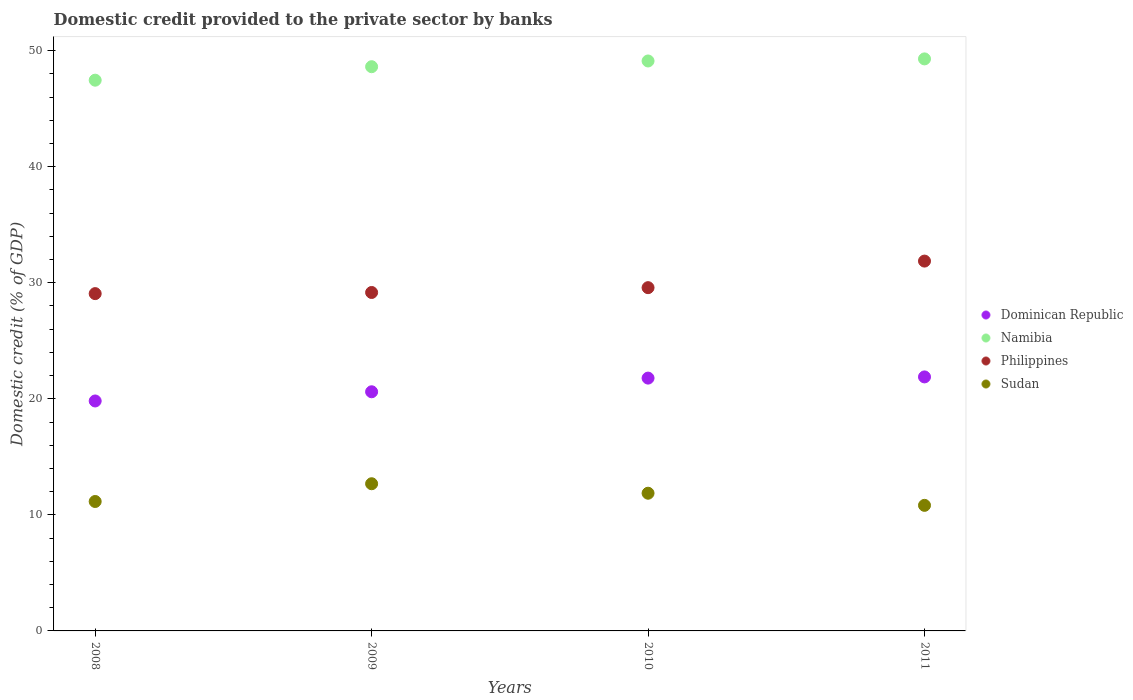How many different coloured dotlines are there?
Make the answer very short. 4. What is the domestic credit provided to the private sector by banks in Dominican Republic in 2009?
Give a very brief answer. 20.61. Across all years, what is the maximum domestic credit provided to the private sector by banks in Sudan?
Provide a short and direct response. 12.68. Across all years, what is the minimum domestic credit provided to the private sector by banks in Sudan?
Offer a very short reply. 10.82. In which year was the domestic credit provided to the private sector by banks in Philippines minimum?
Your response must be concise. 2008. What is the total domestic credit provided to the private sector by banks in Philippines in the graph?
Offer a terse response. 119.67. What is the difference between the domestic credit provided to the private sector by banks in Namibia in 2008 and that in 2011?
Ensure brevity in your answer.  -1.83. What is the difference between the domestic credit provided to the private sector by banks in Sudan in 2011 and the domestic credit provided to the private sector by banks in Dominican Republic in 2009?
Keep it short and to the point. -9.79. What is the average domestic credit provided to the private sector by banks in Namibia per year?
Provide a short and direct response. 48.62. In the year 2010, what is the difference between the domestic credit provided to the private sector by banks in Philippines and domestic credit provided to the private sector by banks in Namibia?
Your answer should be very brief. -19.53. What is the ratio of the domestic credit provided to the private sector by banks in Philippines in 2010 to that in 2011?
Provide a succinct answer. 0.93. Is the difference between the domestic credit provided to the private sector by banks in Philippines in 2009 and 2010 greater than the difference between the domestic credit provided to the private sector by banks in Namibia in 2009 and 2010?
Your answer should be compact. Yes. What is the difference between the highest and the second highest domestic credit provided to the private sector by banks in Philippines?
Your answer should be compact. 2.29. What is the difference between the highest and the lowest domestic credit provided to the private sector by banks in Sudan?
Offer a very short reply. 1.86. In how many years, is the domestic credit provided to the private sector by banks in Dominican Republic greater than the average domestic credit provided to the private sector by banks in Dominican Republic taken over all years?
Offer a terse response. 2. Is it the case that in every year, the sum of the domestic credit provided to the private sector by banks in Philippines and domestic credit provided to the private sector by banks in Dominican Republic  is greater than the sum of domestic credit provided to the private sector by banks in Namibia and domestic credit provided to the private sector by banks in Sudan?
Provide a short and direct response. No. Is the domestic credit provided to the private sector by banks in Sudan strictly greater than the domestic credit provided to the private sector by banks in Namibia over the years?
Your answer should be very brief. No. Is the domestic credit provided to the private sector by banks in Philippines strictly less than the domestic credit provided to the private sector by banks in Dominican Republic over the years?
Provide a succinct answer. No. How many dotlines are there?
Ensure brevity in your answer.  4. How many years are there in the graph?
Provide a succinct answer. 4. Are the values on the major ticks of Y-axis written in scientific E-notation?
Provide a succinct answer. No. Does the graph contain any zero values?
Keep it short and to the point. No. Where does the legend appear in the graph?
Offer a very short reply. Center right. How are the legend labels stacked?
Your answer should be very brief. Vertical. What is the title of the graph?
Provide a succinct answer. Domestic credit provided to the private sector by banks. What is the label or title of the X-axis?
Provide a short and direct response. Years. What is the label or title of the Y-axis?
Ensure brevity in your answer.  Domestic credit (% of GDP). What is the Domestic credit (% of GDP) of Dominican Republic in 2008?
Your answer should be compact. 19.81. What is the Domestic credit (% of GDP) of Namibia in 2008?
Your answer should be very brief. 47.46. What is the Domestic credit (% of GDP) of Philippines in 2008?
Your response must be concise. 29.06. What is the Domestic credit (% of GDP) in Sudan in 2008?
Give a very brief answer. 11.15. What is the Domestic credit (% of GDP) of Dominican Republic in 2009?
Offer a very short reply. 20.61. What is the Domestic credit (% of GDP) in Namibia in 2009?
Give a very brief answer. 48.62. What is the Domestic credit (% of GDP) in Philippines in 2009?
Offer a very short reply. 29.16. What is the Domestic credit (% of GDP) in Sudan in 2009?
Ensure brevity in your answer.  12.68. What is the Domestic credit (% of GDP) of Dominican Republic in 2010?
Give a very brief answer. 21.79. What is the Domestic credit (% of GDP) of Namibia in 2010?
Your answer should be very brief. 49.11. What is the Domestic credit (% of GDP) of Philippines in 2010?
Give a very brief answer. 29.58. What is the Domestic credit (% of GDP) in Sudan in 2010?
Give a very brief answer. 11.87. What is the Domestic credit (% of GDP) of Dominican Republic in 2011?
Ensure brevity in your answer.  21.89. What is the Domestic credit (% of GDP) of Namibia in 2011?
Your answer should be very brief. 49.29. What is the Domestic credit (% of GDP) of Philippines in 2011?
Make the answer very short. 31.87. What is the Domestic credit (% of GDP) of Sudan in 2011?
Offer a very short reply. 10.82. Across all years, what is the maximum Domestic credit (% of GDP) in Dominican Republic?
Give a very brief answer. 21.89. Across all years, what is the maximum Domestic credit (% of GDP) in Namibia?
Offer a very short reply. 49.29. Across all years, what is the maximum Domestic credit (% of GDP) in Philippines?
Ensure brevity in your answer.  31.87. Across all years, what is the maximum Domestic credit (% of GDP) in Sudan?
Make the answer very short. 12.68. Across all years, what is the minimum Domestic credit (% of GDP) in Dominican Republic?
Provide a succinct answer. 19.81. Across all years, what is the minimum Domestic credit (% of GDP) of Namibia?
Provide a succinct answer. 47.46. Across all years, what is the minimum Domestic credit (% of GDP) in Philippines?
Give a very brief answer. 29.06. Across all years, what is the minimum Domestic credit (% of GDP) in Sudan?
Offer a very short reply. 10.82. What is the total Domestic credit (% of GDP) in Dominican Republic in the graph?
Provide a short and direct response. 84.09. What is the total Domestic credit (% of GDP) in Namibia in the graph?
Provide a succinct answer. 194.48. What is the total Domestic credit (% of GDP) of Philippines in the graph?
Give a very brief answer. 119.67. What is the total Domestic credit (% of GDP) in Sudan in the graph?
Offer a very short reply. 46.52. What is the difference between the Domestic credit (% of GDP) in Dominican Republic in 2008 and that in 2009?
Your response must be concise. -0.79. What is the difference between the Domestic credit (% of GDP) of Namibia in 2008 and that in 2009?
Make the answer very short. -1.16. What is the difference between the Domestic credit (% of GDP) in Philippines in 2008 and that in 2009?
Ensure brevity in your answer.  -0.1. What is the difference between the Domestic credit (% of GDP) in Sudan in 2008 and that in 2009?
Offer a terse response. -1.53. What is the difference between the Domestic credit (% of GDP) in Dominican Republic in 2008 and that in 2010?
Your answer should be very brief. -1.97. What is the difference between the Domestic credit (% of GDP) in Namibia in 2008 and that in 2010?
Ensure brevity in your answer.  -1.65. What is the difference between the Domestic credit (% of GDP) in Philippines in 2008 and that in 2010?
Provide a succinct answer. -0.51. What is the difference between the Domestic credit (% of GDP) of Sudan in 2008 and that in 2010?
Offer a very short reply. -0.71. What is the difference between the Domestic credit (% of GDP) in Dominican Republic in 2008 and that in 2011?
Ensure brevity in your answer.  -2.07. What is the difference between the Domestic credit (% of GDP) in Namibia in 2008 and that in 2011?
Keep it short and to the point. -1.83. What is the difference between the Domestic credit (% of GDP) of Philippines in 2008 and that in 2011?
Provide a short and direct response. -2.8. What is the difference between the Domestic credit (% of GDP) in Sudan in 2008 and that in 2011?
Ensure brevity in your answer.  0.33. What is the difference between the Domestic credit (% of GDP) of Dominican Republic in 2009 and that in 2010?
Give a very brief answer. -1.18. What is the difference between the Domestic credit (% of GDP) in Namibia in 2009 and that in 2010?
Your response must be concise. -0.49. What is the difference between the Domestic credit (% of GDP) of Philippines in 2009 and that in 2010?
Give a very brief answer. -0.42. What is the difference between the Domestic credit (% of GDP) of Sudan in 2009 and that in 2010?
Offer a terse response. 0.82. What is the difference between the Domestic credit (% of GDP) in Dominican Republic in 2009 and that in 2011?
Keep it short and to the point. -1.28. What is the difference between the Domestic credit (% of GDP) of Namibia in 2009 and that in 2011?
Provide a succinct answer. -0.67. What is the difference between the Domestic credit (% of GDP) in Philippines in 2009 and that in 2011?
Offer a terse response. -2.71. What is the difference between the Domestic credit (% of GDP) in Sudan in 2009 and that in 2011?
Your answer should be compact. 1.86. What is the difference between the Domestic credit (% of GDP) in Dominican Republic in 2010 and that in 2011?
Provide a short and direct response. -0.1. What is the difference between the Domestic credit (% of GDP) in Namibia in 2010 and that in 2011?
Keep it short and to the point. -0.18. What is the difference between the Domestic credit (% of GDP) in Philippines in 2010 and that in 2011?
Provide a succinct answer. -2.29. What is the difference between the Domestic credit (% of GDP) of Sudan in 2010 and that in 2011?
Offer a terse response. 1.04. What is the difference between the Domestic credit (% of GDP) of Dominican Republic in 2008 and the Domestic credit (% of GDP) of Namibia in 2009?
Provide a short and direct response. -28.8. What is the difference between the Domestic credit (% of GDP) in Dominican Republic in 2008 and the Domestic credit (% of GDP) in Philippines in 2009?
Provide a succinct answer. -9.35. What is the difference between the Domestic credit (% of GDP) in Dominican Republic in 2008 and the Domestic credit (% of GDP) in Sudan in 2009?
Your response must be concise. 7.13. What is the difference between the Domestic credit (% of GDP) in Namibia in 2008 and the Domestic credit (% of GDP) in Philippines in 2009?
Keep it short and to the point. 18.29. What is the difference between the Domestic credit (% of GDP) in Namibia in 2008 and the Domestic credit (% of GDP) in Sudan in 2009?
Your answer should be compact. 34.78. What is the difference between the Domestic credit (% of GDP) of Philippines in 2008 and the Domestic credit (% of GDP) of Sudan in 2009?
Ensure brevity in your answer.  16.38. What is the difference between the Domestic credit (% of GDP) of Dominican Republic in 2008 and the Domestic credit (% of GDP) of Namibia in 2010?
Offer a very short reply. -29.3. What is the difference between the Domestic credit (% of GDP) in Dominican Republic in 2008 and the Domestic credit (% of GDP) in Philippines in 2010?
Provide a short and direct response. -9.76. What is the difference between the Domestic credit (% of GDP) in Dominican Republic in 2008 and the Domestic credit (% of GDP) in Sudan in 2010?
Your response must be concise. 7.95. What is the difference between the Domestic credit (% of GDP) of Namibia in 2008 and the Domestic credit (% of GDP) of Philippines in 2010?
Your answer should be very brief. 17.88. What is the difference between the Domestic credit (% of GDP) in Namibia in 2008 and the Domestic credit (% of GDP) in Sudan in 2010?
Provide a succinct answer. 35.59. What is the difference between the Domestic credit (% of GDP) of Philippines in 2008 and the Domestic credit (% of GDP) of Sudan in 2010?
Provide a short and direct response. 17.2. What is the difference between the Domestic credit (% of GDP) in Dominican Republic in 2008 and the Domestic credit (% of GDP) in Namibia in 2011?
Keep it short and to the point. -29.48. What is the difference between the Domestic credit (% of GDP) in Dominican Republic in 2008 and the Domestic credit (% of GDP) in Philippines in 2011?
Keep it short and to the point. -12.05. What is the difference between the Domestic credit (% of GDP) of Dominican Republic in 2008 and the Domestic credit (% of GDP) of Sudan in 2011?
Offer a terse response. 8.99. What is the difference between the Domestic credit (% of GDP) in Namibia in 2008 and the Domestic credit (% of GDP) in Philippines in 2011?
Keep it short and to the point. 15.59. What is the difference between the Domestic credit (% of GDP) in Namibia in 2008 and the Domestic credit (% of GDP) in Sudan in 2011?
Provide a succinct answer. 36.64. What is the difference between the Domestic credit (% of GDP) in Philippines in 2008 and the Domestic credit (% of GDP) in Sudan in 2011?
Give a very brief answer. 18.24. What is the difference between the Domestic credit (% of GDP) of Dominican Republic in 2009 and the Domestic credit (% of GDP) of Namibia in 2010?
Keep it short and to the point. -28.51. What is the difference between the Domestic credit (% of GDP) in Dominican Republic in 2009 and the Domestic credit (% of GDP) in Philippines in 2010?
Keep it short and to the point. -8.97. What is the difference between the Domestic credit (% of GDP) in Dominican Republic in 2009 and the Domestic credit (% of GDP) in Sudan in 2010?
Your response must be concise. 8.74. What is the difference between the Domestic credit (% of GDP) of Namibia in 2009 and the Domestic credit (% of GDP) of Philippines in 2010?
Offer a terse response. 19.04. What is the difference between the Domestic credit (% of GDP) of Namibia in 2009 and the Domestic credit (% of GDP) of Sudan in 2010?
Make the answer very short. 36.75. What is the difference between the Domestic credit (% of GDP) in Philippines in 2009 and the Domestic credit (% of GDP) in Sudan in 2010?
Provide a succinct answer. 17.3. What is the difference between the Domestic credit (% of GDP) of Dominican Republic in 2009 and the Domestic credit (% of GDP) of Namibia in 2011?
Your response must be concise. -28.68. What is the difference between the Domestic credit (% of GDP) of Dominican Republic in 2009 and the Domestic credit (% of GDP) of Philippines in 2011?
Offer a very short reply. -11.26. What is the difference between the Domestic credit (% of GDP) of Dominican Republic in 2009 and the Domestic credit (% of GDP) of Sudan in 2011?
Provide a short and direct response. 9.79. What is the difference between the Domestic credit (% of GDP) in Namibia in 2009 and the Domestic credit (% of GDP) in Philippines in 2011?
Provide a short and direct response. 16.75. What is the difference between the Domestic credit (% of GDP) of Namibia in 2009 and the Domestic credit (% of GDP) of Sudan in 2011?
Your response must be concise. 37.8. What is the difference between the Domestic credit (% of GDP) of Philippines in 2009 and the Domestic credit (% of GDP) of Sudan in 2011?
Offer a very short reply. 18.34. What is the difference between the Domestic credit (% of GDP) of Dominican Republic in 2010 and the Domestic credit (% of GDP) of Namibia in 2011?
Provide a short and direct response. -27.51. What is the difference between the Domestic credit (% of GDP) in Dominican Republic in 2010 and the Domestic credit (% of GDP) in Philippines in 2011?
Your answer should be very brief. -10.08. What is the difference between the Domestic credit (% of GDP) in Dominican Republic in 2010 and the Domestic credit (% of GDP) in Sudan in 2011?
Provide a short and direct response. 10.96. What is the difference between the Domestic credit (% of GDP) in Namibia in 2010 and the Domestic credit (% of GDP) in Philippines in 2011?
Your answer should be compact. 17.24. What is the difference between the Domestic credit (% of GDP) in Namibia in 2010 and the Domestic credit (% of GDP) in Sudan in 2011?
Your answer should be compact. 38.29. What is the difference between the Domestic credit (% of GDP) of Philippines in 2010 and the Domestic credit (% of GDP) of Sudan in 2011?
Ensure brevity in your answer.  18.76. What is the average Domestic credit (% of GDP) in Dominican Republic per year?
Offer a very short reply. 21.02. What is the average Domestic credit (% of GDP) in Namibia per year?
Give a very brief answer. 48.62. What is the average Domestic credit (% of GDP) in Philippines per year?
Offer a terse response. 29.92. What is the average Domestic credit (% of GDP) in Sudan per year?
Offer a very short reply. 11.63. In the year 2008, what is the difference between the Domestic credit (% of GDP) in Dominican Republic and Domestic credit (% of GDP) in Namibia?
Your response must be concise. -27.64. In the year 2008, what is the difference between the Domestic credit (% of GDP) in Dominican Republic and Domestic credit (% of GDP) in Philippines?
Ensure brevity in your answer.  -9.25. In the year 2008, what is the difference between the Domestic credit (% of GDP) in Dominican Republic and Domestic credit (% of GDP) in Sudan?
Provide a short and direct response. 8.66. In the year 2008, what is the difference between the Domestic credit (% of GDP) of Namibia and Domestic credit (% of GDP) of Philippines?
Make the answer very short. 18.39. In the year 2008, what is the difference between the Domestic credit (% of GDP) in Namibia and Domestic credit (% of GDP) in Sudan?
Your response must be concise. 36.3. In the year 2008, what is the difference between the Domestic credit (% of GDP) in Philippines and Domestic credit (% of GDP) in Sudan?
Provide a short and direct response. 17.91. In the year 2009, what is the difference between the Domestic credit (% of GDP) of Dominican Republic and Domestic credit (% of GDP) of Namibia?
Offer a very short reply. -28.01. In the year 2009, what is the difference between the Domestic credit (% of GDP) of Dominican Republic and Domestic credit (% of GDP) of Philippines?
Ensure brevity in your answer.  -8.56. In the year 2009, what is the difference between the Domestic credit (% of GDP) of Dominican Republic and Domestic credit (% of GDP) of Sudan?
Your response must be concise. 7.92. In the year 2009, what is the difference between the Domestic credit (% of GDP) of Namibia and Domestic credit (% of GDP) of Philippines?
Provide a succinct answer. 19.46. In the year 2009, what is the difference between the Domestic credit (% of GDP) in Namibia and Domestic credit (% of GDP) in Sudan?
Offer a very short reply. 35.94. In the year 2009, what is the difference between the Domestic credit (% of GDP) in Philippines and Domestic credit (% of GDP) in Sudan?
Keep it short and to the point. 16.48. In the year 2010, what is the difference between the Domestic credit (% of GDP) of Dominican Republic and Domestic credit (% of GDP) of Namibia?
Provide a succinct answer. -27.33. In the year 2010, what is the difference between the Domestic credit (% of GDP) in Dominican Republic and Domestic credit (% of GDP) in Philippines?
Give a very brief answer. -7.79. In the year 2010, what is the difference between the Domestic credit (% of GDP) of Dominican Republic and Domestic credit (% of GDP) of Sudan?
Provide a succinct answer. 9.92. In the year 2010, what is the difference between the Domestic credit (% of GDP) of Namibia and Domestic credit (% of GDP) of Philippines?
Your response must be concise. 19.53. In the year 2010, what is the difference between the Domestic credit (% of GDP) in Namibia and Domestic credit (% of GDP) in Sudan?
Offer a terse response. 37.25. In the year 2010, what is the difference between the Domestic credit (% of GDP) in Philippines and Domestic credit (% of GDP) in Sudan?
Give a very brief answer. 17.71. In the year 2011, what is the difference between the Domestic credit (% of GDP) in Dominican Republic and Domestic credit (% of GDP) in Namibia?
Make the answer very short. -27.4. In the year 2011, what is the difference between the Domestic credit (% of GDP) of Dominican Republic and Domestic credit (% of GDP) of Philippines?
Ensure brevity in your answer.  -9.98. In the year 2011, what is the difference between the Domestic credit (% of GDP) of Dominican Republic and Domestic credit (% of GDP) of Sudan?
Offer a terse response. 11.07. In the year 2011, what is the difference between the Domestic credit (% of GDP) of Namibia and Domestic credit (% of GDP) of Philippines?
Keep it short and to the point. 17.42. In the year 2011, what is the difference between the Domestic credit (% of GDP) of Namibia and Domestic credit (% of GDP) of Sudan?
Provide a succinct answer. 38.47. In the year 2011, what is the difference between the Domestic credit (% of GDP) of Philippines and Domestic credit (% of GDP) of Sudan?
Your response must be concise. 21.05. What is the ratio of the Domestic credit (% of GDP) in Dominican Republic in 2008 to that in 2009?
Ensure brevity in your answer.  0.96. What is the ratio of the Domestic credit (% of GDP) of Namibia in 2008 to that in 2009?
Offer a very short reply. 0.98. What is the ratio of the Domestic credit (% of GDP) in Sudan in 2008 to that in 2009?
Provide a succinct answer. 0.88. What is the ratio of the Domestic credit (% of GDP) in Dominican Republic in 2008 to that in 2010?
Keep it short and to the point. 0.91. What is the ratio of the Domestic credit (% of GDP) of Namibia in 2008 to that in 2010?
Provide a succinct answer. 0.97. What is the ratio of the Domestic credit (% of GDP) of Philippines in 2008 to that in 2010?
Provide a succinct answer. 0.98. What is the ratio of the Domestic credit (% of GDP) of Sudan in 2008 to that in 2010?
Offer a very short reply. 0.94. What is the ratio of the Domestic credit (% of GDP) in Dominican Republic in 2008 to that in 2011?
Provide a short and direct response. 0.91. What is the ratio of the Domestic credit (% of GDP) in Namibia in 2008 to that in 2011?
Your response must be concise. 0.96. What is the ratio of the Domestic credit (% of GDP) in Philippines in 2008 to that in 2011?
Ensure brevity in your answer.  0.91. What is the ratio of the Domestic credit (% of GDP) of Sudan in 2008 to that in 2011?
Ensure brevity in your answer.  1.03. What is the ratio of the Domestic credit (% of GDP) of Dominican Republic in 2009 to that in 2010?
Your answer should be compact. 0.95. What is the ratio of the Domestic credit (% of GDP) of Namibia in 2009 to that in 2010?
Your response must be concise. 0.99. What is the ratio of the Domestic credit (% of GDP) of Philippines in 2009 to that in 2010?
Your answer should be very brief. 0.99. What is the ratio of the Domestic credit (% of GDP) of Sudan in 2009 to that in 2010?
Provide a short and direct response. 1.07. What is the ratio of the Domestic credit (% of GDP) of Dominican Republic in 2009 to that in 2011?
Offer a very short reply. 0.94. What is the ratio of the Domestic credit (% of GDP) of Namibia in 2009 to that in 2011?
Give a very brief answer. 0.99. What is the ratio of the Domestic credit (% of GDP) of Philippines in 2009 to that in 2011?
Give a very brief answer. 0.92. What is the ratio of the Domestic credit (% of GDP) of Sudan in 2009 to that in 2011?
Ensure brevity in your answer.  1.17. What is the ratio of the Domestic credit (% of GDP) in Dominican Republic in 2010 to that in 2011?
Offer a very short reply. 1. What is the ratio of the Domestic credit (% of GDP) in Philippines in 2010 to that in 2011?
Give a very brief answer. 0.93. What is the ratio of the Domestic credit (% of GDP) of Sudan in 2010 to that in 2011?
Your answer should be very brief. 1.1. What is the difference between the highest and the second highest Domestic credit (% of GDP) in Dominican Republic?
Offer a very short reply. 0.1. What is the difference between the highest and the second highest Domestic credit (% of GDP) of Namibia?
Give a very brief answer. 0.18. What is the difference between the highest and the second highest Domestic credit (% of GDP) of Philippines?
Provide a succinct answer. 2.29. What is the difference between the highest and the second highest Domestic credit (% of GDP) of Sudan?
Your answer should be compact. 0.82. What is the difference between the highest and the lowest Domestic credit (% of GDP) of Dominican Republic?
Your response must be concise. 2.07. What is the difference between the highest and the lowest Domestic credit (% of GDP) of Namibia?
Your response must be concise. 1.83. What is the difference between the highest and the lowest Domestic credit (% of GDP) in Philippines?
Your answer should be very brief. 2.8. What is the difference between the highest and the lowest Domestic credit (% of GDP) of Sudan?
Make the answer very short. 1.86. 